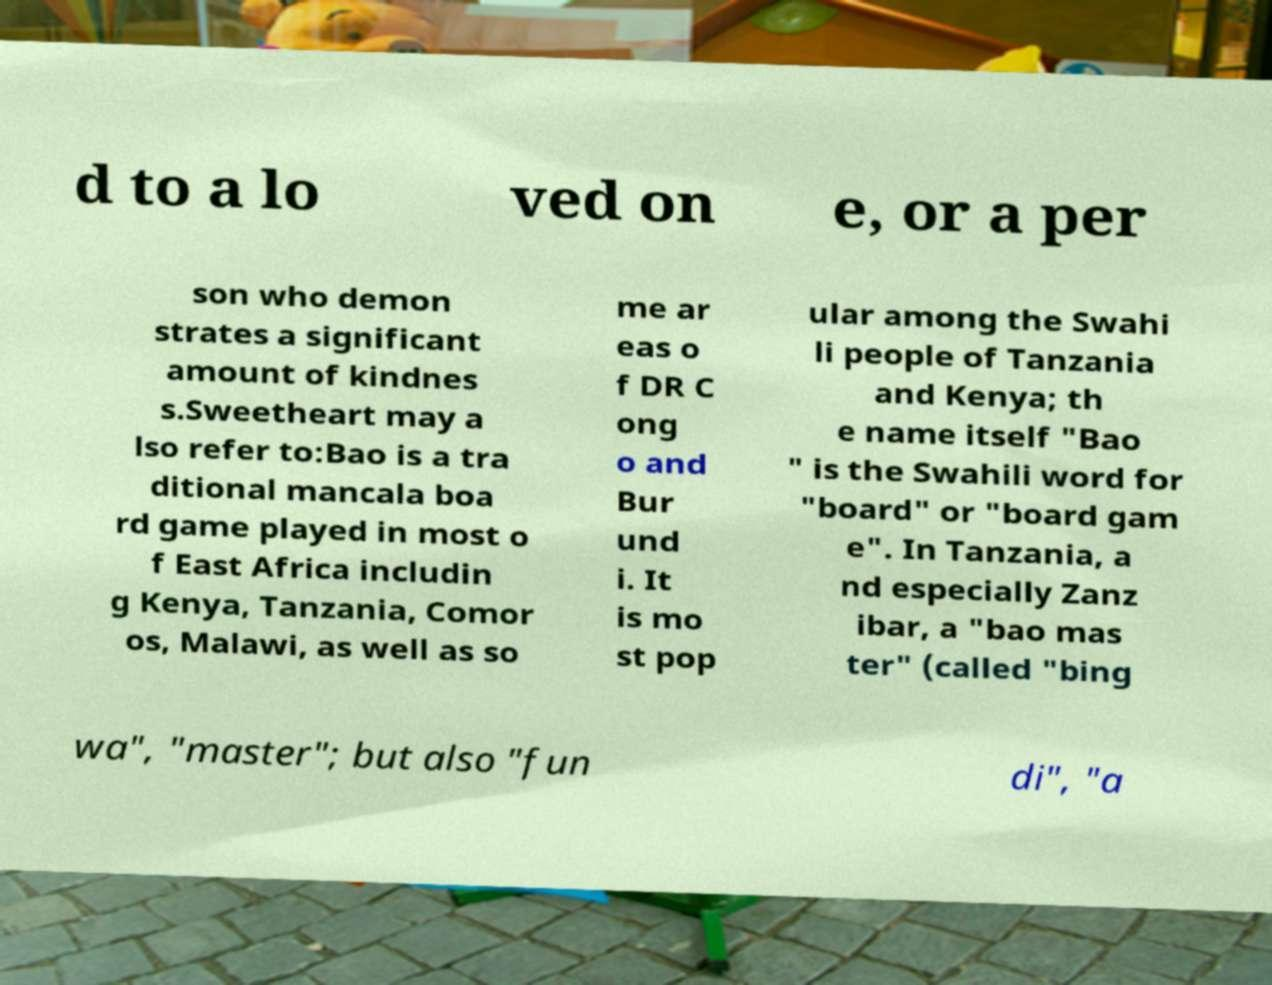For documentation purposes, I need the text within this image transcribed. Could you provide that? d to a lo ved on e, or a per son who demon strates a significant amount of kindnes s.Sweetheart may a lso refer to:Bao is a tra ditional mancala boa rd game played in most o f East Africa includin g Kenya, Tanzania, Comor os, Malawi, as well as so me ar eas o f DR C ong o and Bur und i. It is mo st pop ular among the Swahi li people of Tanzania and Kenya; th e name itself "Bao " is the Swahili word for "board" or "board gam e". In Tanzania, a nd especially Zanz ibar, a "bao mas ter" (called "bing wa", "master"; but also "fun di", "a 